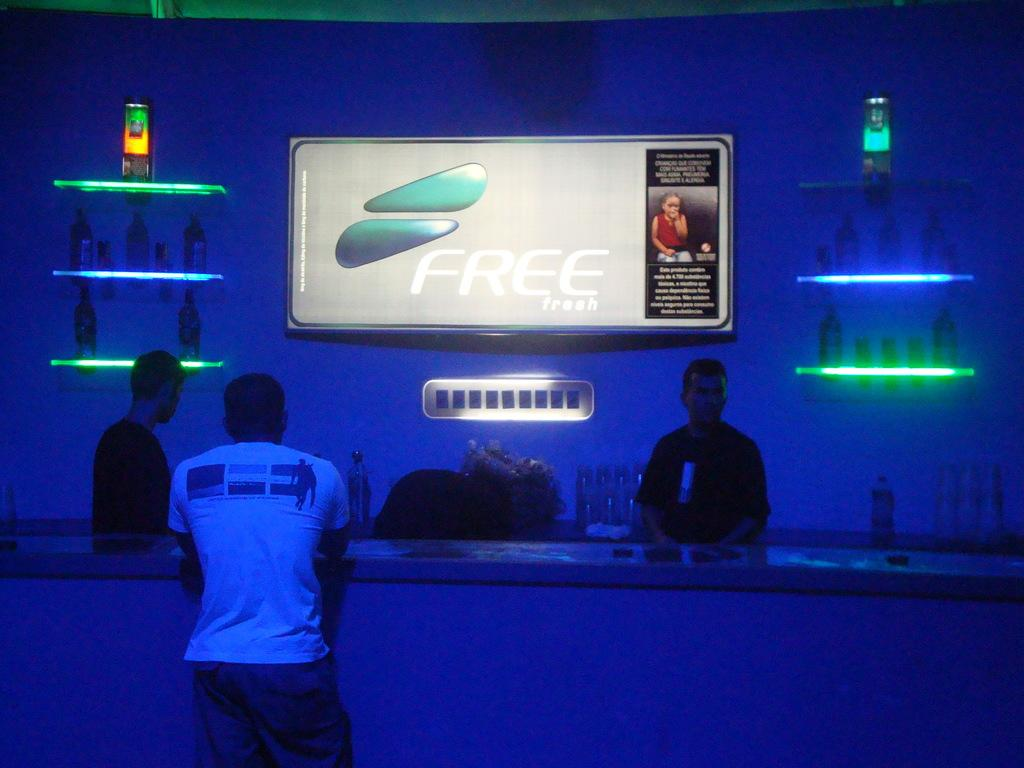What is the man in the image doing? The man is standing at the table in the image. What can be seen on the table? There are items on the table in the image. What is located in the background of the image? There are wine bottles on racks and a screen in the background, as well as a wall. What type of joke is being told by the shirt in the image? There is no shirt present in the image, and therefore no joke can be told by it. 